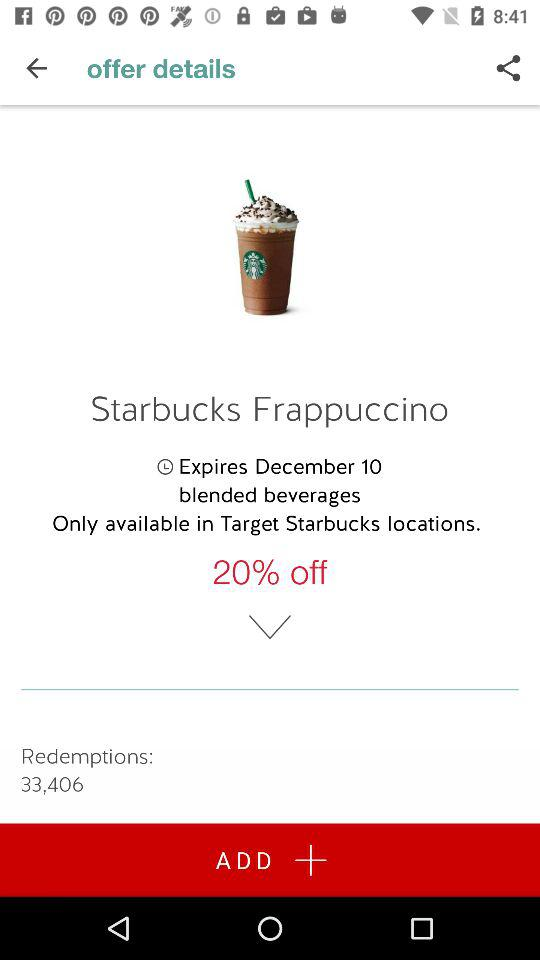How many redemptions are there for this offer?
Answer the question using a single word or phrase. 33,406 